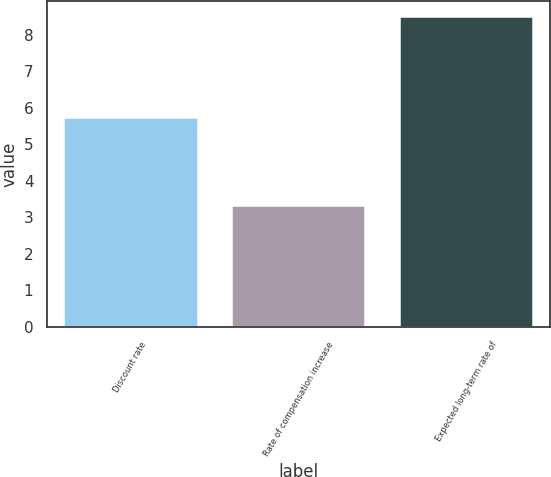Convert chart. <chart><loc_0><loc_0><loc_500><loc_500><bar_chart><fcel>Discount rate<fcel>Rate of compensation increase<fcel>Expected long-term rate of<nl><fcel>5.75<fcel>3.33<fcel>8.5<nl></chart> 